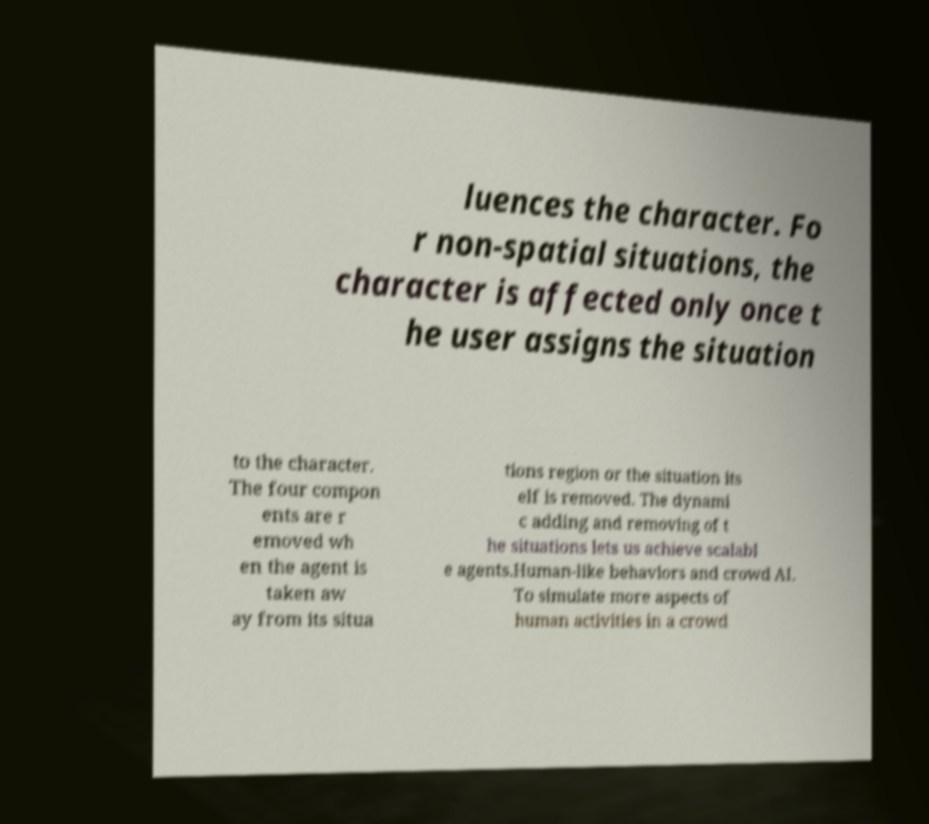Can you accurately transcribe the text from the provided image for me? luences the character. Fo r non-spatial situations, the character is affected only once t he user assigns the situation to the character. The four compon ents are r emoved wh en the agent is taken aw ay from its situa tions region or the situation its elf is removed. The dynami c adding and removing of t he situations lets us achieve scalabl e agents.Human-like behaviors and crowd AI. To simulate more aspects of human activities in a crowd 